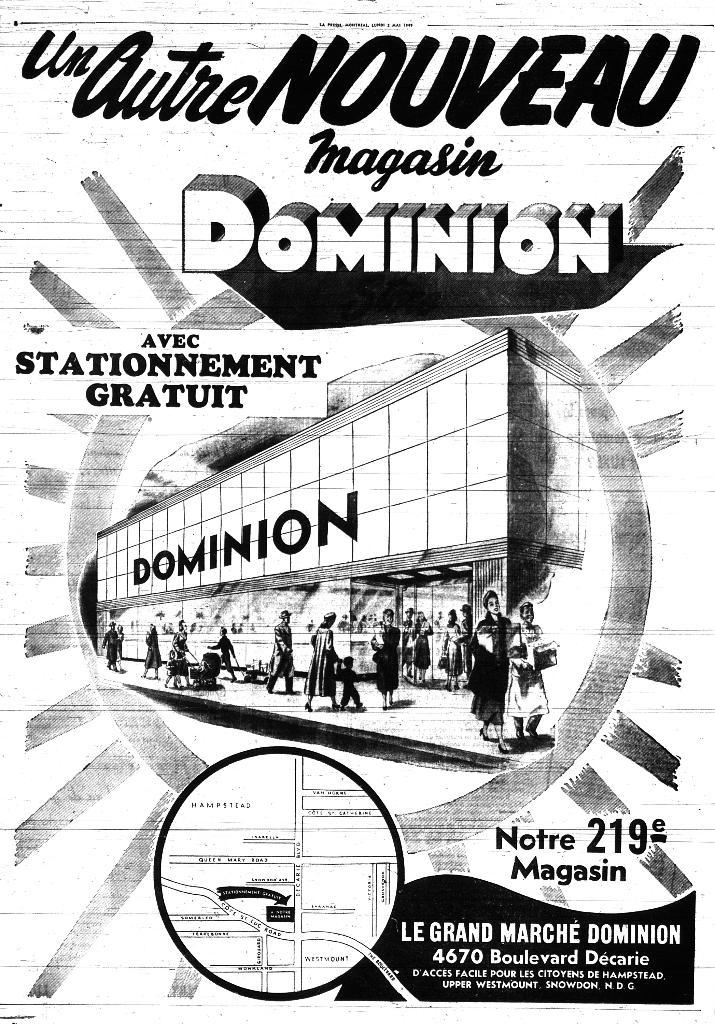Is the dominion a magazine?
Provide a succinct answer. Yes. What volume number is this magazine?
Provide a short and direct response. 219. 